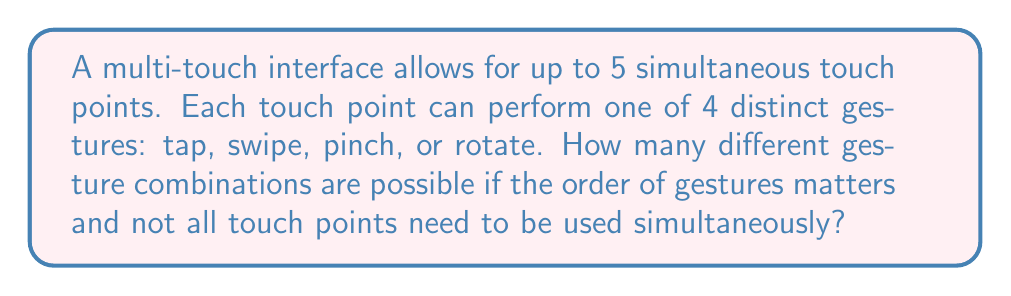Give your solution to this math problem. Let's approach this step-by-step:

1) First, we need to consider that for each touch point, we have 5 options: the 4 gestures or not using that touch point at all. This gives us 5 choices per touch point.

2) We have 5 touch points in total, and the order matters. This scenario fits the multiplication principle of counting.

3) The total number of combinations can be calculated as:

   $$ 5^5 $$

4) This is because for each touch point, we have 5 choices, and we're making this choice 5 times (once for each touch point).

5) Let's calculate:

   $$ 5^5 = 5 \times 5 \times 5 \times 5 \times 5 = 3125 $$

6) However, we need to exclude the case where no touch points are used at all (as this wouldn't be a gesture). So we subtract 1 from our total:

   $$ 3125 - 1 = 3124 $$

Therefore, there are 3124 possible gesture combinations for this multi-touch interface.
Answer: 3124 